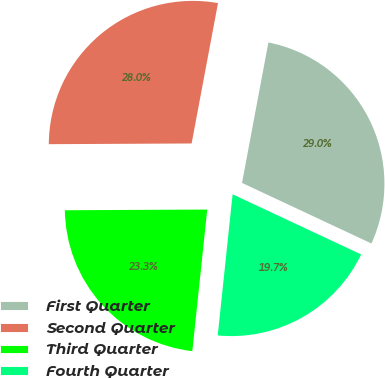Convert chart to OTSL. <chart><loc_0><loc_0><loc_500><loc_500><pie_chart><fcel>First Quarter<fcel>Second Quarter<fcel>Third Quarter<fcel>Fourth Quarter<nl><fcel>29.01%<fcel>28.03%<fcel>23.25%<fcel>19.7%<nl></chart> 